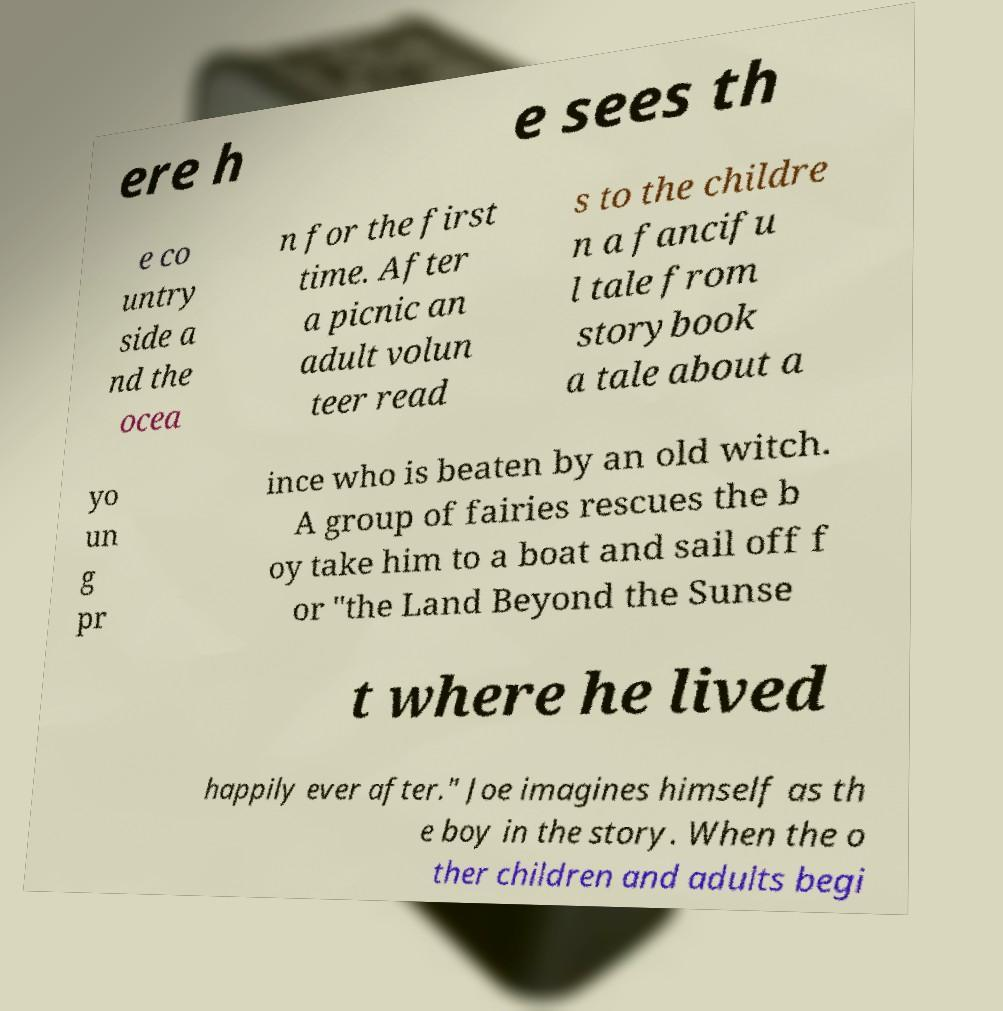For documentation purposes, I need the text within this image transcribed. Could you provide that? ere h e sees th e co untry side a nd the ocea n for the first time. After a picnic an adult volun teer read s to the childre n a fancifu l tale from storybook a tale about a yo un g pr ince who is beaten by an old witch. A group of fairies rescues the b oy take him to a boat and sail off f or "the Land Beyond the Sunse t where he lived happily ever after." Joe imagines himself as th e boy in the story. When the o ther children and adults begi 